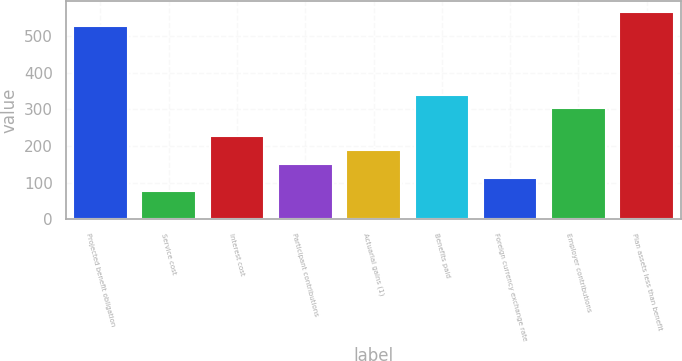Convert chart to OTSL. <chart><loc_0><loc_0><loc_500><loc_500><bar_chart><fcel>Projected benefit obligation<fcel>Service cost<fcel>Interest cost<fcel>Participant contributions<fcel>Actuarial gains (1)<fcel>Benefits paid<fcel>Foreign currency exchange rate<fcel>Employer contributions<fcel>Plan assets less than benefit<nl><fcel>528.8<fcel>76.4<fcel>227.2<fcel>151.8<fcel>189.5<fcel>340.3<fcel>114.1<fcel>302.6<fcel>566.5<nl></chart> 